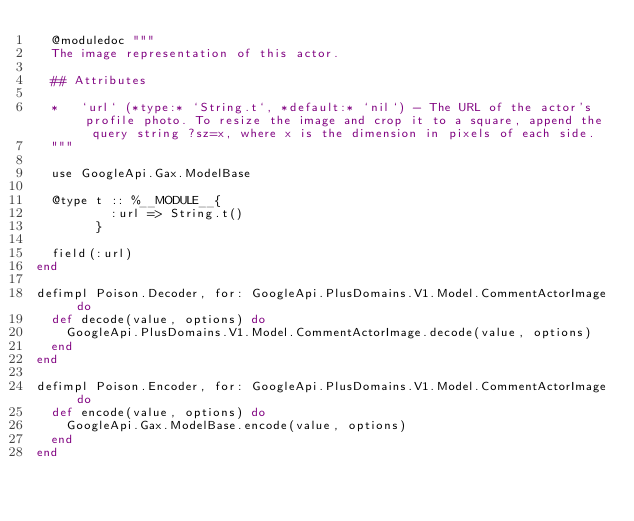Convert code to text. <code><loc_0><loc_0><loc_500><loc_500><_Elixir_>  @moduledoc """
  The image representation of this actor.

  ## Attributes

  *   `url` (*type:* `String.t`, *default:* `nil`) - The URL of the actor's profile photo. To resize the image and crop it to a square, append the query string ?sz=x, where x is the dimension in pixels of each side.
  """

  use GoogleApi.Gax.ModelBase

  @type t :: %__MODULE__{
          :url => String.t()
        }

  field(:url)
end

defimpl Poison.Decoder, for: GoogleApi.PlusDomains.V1.Model.CommentActorImage do
  def decode(value, options) do
    GoogleApi.PlusDomains.V1.Model.CommentActorImage.decode(value, options)
  end
end

defimpl Poison.Encoder, for: GoogleApi.PlusDomains.V1.Model.CommentActorImage do
  def encode(value, options) do
    GoogleApi.Gax.ModelBase.encode(value, options)
  end
end
</code> 